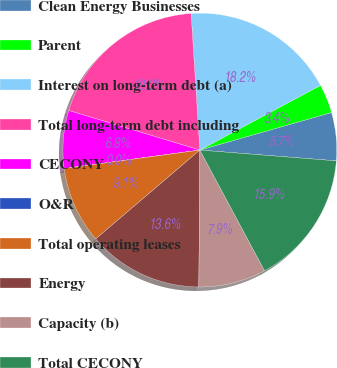Convert chart to OTSL. <chart><loc_0><loc_0><loc_500><loc_500><pie_chart><fcel>Clean Energy Businesses<fcel>Parent<fcel>Interest on long-term debt (a)<fcel>Total long-term debt including<fcel>CECONY<fcel>O&R<fcel>Total operating leases<fcel>Energy<fcel>Capacity (b)<fcel>Total CECONY<nl><fcel>5.68%<fcel>3.41%<fcel>18.18%<fcel>19.32%<fcel>6.82%<fcel>0.0%<fcel>9.09%<fcel>13.64%<fcel>7.95%<fcel>15.91%<nl></chart> 